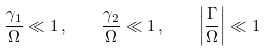Convert formula to latex. <formula><loc_0><loc_0><loc_500><loc_500>\frac { \gamma _ { 1 } } { \Omega } \ll 1 \, , \quad \frac { \gamma _ { 2 } } { \Omega } \ll 1 \, , \quad \left | \frac { \Gamma } { \Omega } \right | \ll 1</formula> 